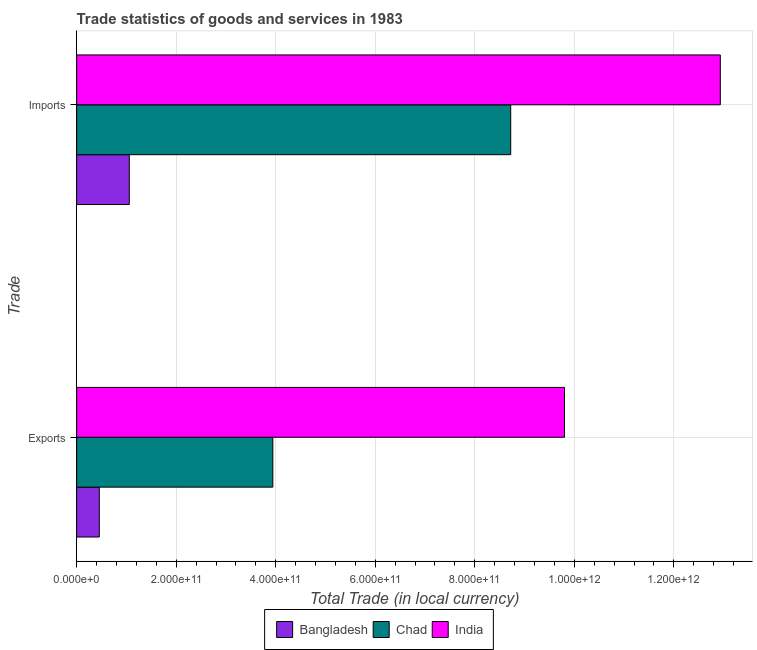How many different coloured bars are there?
Make the answer very short. 3. Are the number of bars per tick equal to the number of legend labels?
Provide a succinct answer. Yes. What is the label of the 2nd group of bars from the top?
Your answer should be compact. Exports. What is the imports of goods and services in Bangladesh?
Offer a very short reply. 1.06e+11. Across all countries, what is the maximum imports of goods and services?
Provide a short and direct response. 1.29e+12. Across all countries, what is the minimum export of goods and services?
Keep it short and to the point. 4.55e+1. In which country was the export of goods and services maximum?
Keep it short and to the point. India. In which country was the export of goods and services minimum?
Your response must be concise. Bangladesh. What is the total imports of goods and services in the graph?
Offer a terse response. 2.27e+12. What is the difference between the imports of goods and services in Chad and that in Bangladesh?
Provide a succinct answer. 7.66e+11. What is the difference between the imports of goods and services in India and the export of goods and services in Chad?
Provide a short and direct response. 8.99e+11. What is the average imports of goods and services per country?
Provide a succinct answer. 7.57e+11. What is the difference between the export of goods and services and imports of goods and services in India?
Your response must be concise. -3.13e+11. In how many countries, is the imports of goods and services greater than 240000000000 LCU?
Offer a very short reply. 2. What is the ratio of the imports of goods and services in India to that in Chad?
Ensure brevity in your answer.  1.48. Is the imports of goods and services in Bangladesh less than that in India?
Give a very brief answer. Yes. What does the 1st bar from the top in Imports represents?
Make the answer very short. India. What does the 2nd bar from the bottom in Imports represents?
Make the answer very short. Chad. How many bars are there?
Offer a very short reply. 6. Are all the bars in the graph horizontal?
Provide a succinct answer. Yes. What is the difference between two consecutive major ticks on the X-axis?
Offer a terse response. 2.00e+11. Are the values on the major ticks of X-axis written in scientific E-notation?
Offer a terse response. Yes. Does the graph contain any zero values?
Your answer should be compact. No. Does the graph contain grids?
Offer a very short reply. Yes. Where does the legend appear in the graph?
Keep it short and to the point. Bottom center. How are the legend labels stacked?
Give a very brief answer. Horizontal. What is the title of the graph?
Give a very brief answer. Trade statistics of goods and services in 1983. What is the label or title of the X-axis?
Offer a very short reply. Total Trade (in local currency). What is the label or title of the Y-axis?
Your answer should be very brief. Trade. What is the Total Trade (in local currency) in Bangladesh in Exports?
Make the answer very short. 4.55e+1. What is the Total Trade (in local currency) of Chad in Exports?
Ensure brevity in your answer.  3.94e+11. What is the Total Trade (in local currency) in India in Exports?
Offer a terse response. 9.80e+11. What is the Total Trade (in local currency) of Bangladesh in Imports?
Provide a succinct answer. 1.06e+11. What is the Total Trade (in local currency) of Chad in Imports?
Make the answer very short. 8.72e+11. What is the Total Trade (in local currency) of India in Imports?
Ensure brevity in your answer.  1.29e+12. Across all Trade, what is the maximum Total Trade (in local currency) of Bangladesh?
Provide a short and direct response. 1.06e+11. Across all Trade, what is the maximum Total Trade (in local currency) of Chad?
Give a very brief answer. 8.72e+11. Across all Trade, what is the maximum Total Trade (in local currency) of India?
Ensure brevity in your answer.  1.29e+12. Across all Trade, what is the minimum Total Trade (in local currency) in Bangladesh?
Keep it short and to the point. 4.55e+1. Across all Trade, what is the minimum Total Trade (in local currency) of Chad?
Keep it short and to the point. 3.94e+11. Across all Trade, what is the minimum Total Trade (in local currency) in India?
Your response must be concise. 9.80e+11. What is the total Total Trade (in local currency) of Bangladesh in the graph?
Offer a very short reply. 1.51e+11. What is the total Total Trade (in local currency) in Chad in the graph?
Keep it short and to the point. 1.27e+12. What is the total Total Trade (in local currency) in India in the graph?
Make the answer very short. 2.27e+12. What is the difference between the Total Trade (in local currency) of Bangladesh in Exports and that in Imports?
Ensure brevity in your answer.  -6.03e+1. What is the difference between the Total Trade (in local currency) in Chad in Exports and that in Imports?
Your response must be concise. -4.78e+11. What is the difference between the Total Trade (in local currency) of India in Exports and that in Imports?
Keep it short and to the point. -3.13e+11. What is the difference between the Total Trade (in local currency) of Bangladesh in Exports and the Total Trade (in local currency) of Chad in Imports?
Your response must be concise. -8.27e+11. What is the difference between the Total Trade (in local currency) of Bangladesh in Exports and the Total Trade (in local currency) of India in Imports?
Your answer should be very brief. -1.25e+12. What is the difference between the Total Trade (in local currency) of Chad in Exports and the Total Trade (in local currency) of India in Imports?
Your response must be concise. -8.99e+11. What is the average Total Trade (in local currency) in Bangladesh per Trade?
Provide a succinct answer. 7.56e+1. What is the average Total Trade (in local currency) of Chad per Trade?
Give a very brief answer. 6.33e+11. What is the average Total Trade (in local currency) of India per Trade?
Keep it short and to the point. 1.14e+12. What is the difference between the Total Trade (in local currency) of Bangladesh and Total Trade (in local currency) of Chad in Exports?
Give a very brief answer. -3.49e+11. What is the difference between the Total Trade (in local currency) of Bangladesh and Total Trade (in local currency) of India in Exports?
Ensure brevity in your answer.  -9.35e+11. What is the difference between the Total Trade (in local currency) of Chad and Total Trade (in local currency) of India in Exports?
Your response must be concise. -5.86e+11. What is the difference between the Total Trade (in local currency) in Bangladesh and Total Trade (in local currency) in Chad in Imports?
Provide a short and direct response. -7.66e+11. What is the difference between the Total Trade (in local currency) of Bangladesh and Total Trade (in local currency) of India in Imports?
Provide a short and direct response. -1.19e+12. What is the difference between the Total Trade (in local currency) in Chad and Total Trade (in local currency) in India in Imports?
Offer a very short reply. -4.21e+11. What is the ratio of the Total Trade (in local currency) in Bangladesh in Exports to that in Imports?
Provide a short and direct response. 0.43. What is the ratio of the Total Trade (in local currency) of Chad in Exports to that in Imports?
Provide a succinct answer. 0.45. What is the ratio of the Total Trade (in local currency) in India in Exports to that in Imports?
Keep it short and to the point. 0.76. What is the difference between the highest and the second highest Total Trade (in local currency) in Bangladesh?
Your answer should be very brief. 6.03e+1. What is the difference between the highest and the second highest Total Trade (in local currency) of Chad?
Provide a short and direct response. 4.78e+11. What is the difference between the highest and the second highest Total Trade (in local currency) in India?
Your response must be concise. 3.13e+11. What is the difference between the highest and the lowest Total Trade (in local currency) of Bangladesh?
Give a very brief answer. 6.03e+1. What is the difference between the highest and the lowest Total Trade (in local currency) in Chad?
Ensure brevity in your answer.  4.78e+11. What is the difference between the highest and the lowest Total Trade (in local currency) in India?
Ensure brevity in your answer.  3.13e+11. 